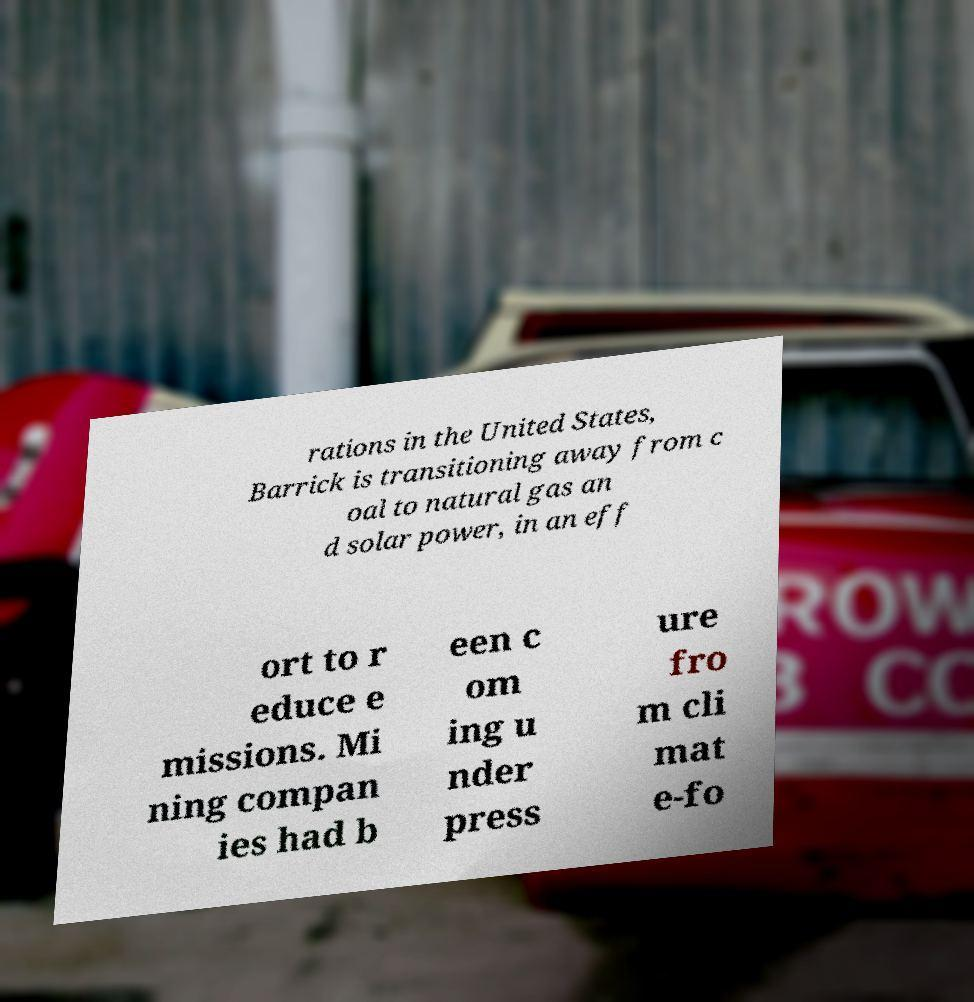Could you extract and type out the text from this image? rations in the United States, Barrick is transitioning away from c oal to natural gas an d solar power, in an eff ort to r educe e missions. Mi ning compan ies had b een c om ing u nder press ure fro m cli mat e-fo 